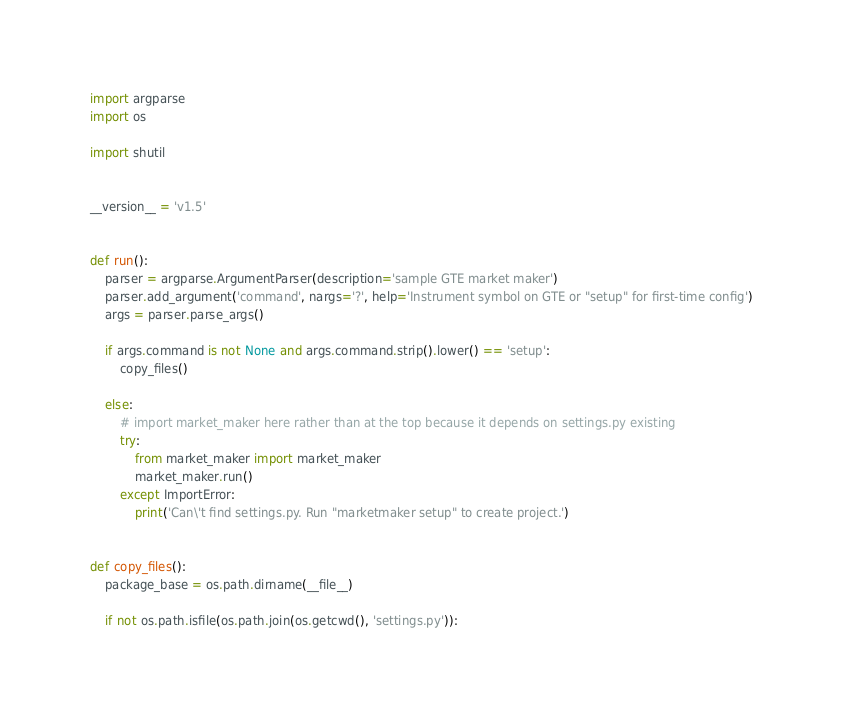<code> <loc_0><loc_0><loc_500><loc_500><_Python_>import argparse
import os

import shutil


__version__ = 'v1.5'


def run():
    parser = argparse.ArgumentParser(description='sample GTE market maker')
    parser.add_argument('command', nargs='?', help='Instrument symbol on GTE or "setup" for first-time config')
    args = parser.parse_args()

    if args.command is not None and args.command.strip().lower() == 'setup':
        copy_files()

    else:
        # import market_maker here rather than at the top because it depends on settings.py existing
        try:
            from market_maker import market_maker
            market_maker.run()
        except ImportError:
            print('Can\'t find settings.py. Run "marketmaker setup" to create project.')


def copy_files():
    package_base = os.path.dirname(__file__)

    if not os.path.isfile(os.path.join(os.getcwd(), 'settings.py')):</code> 